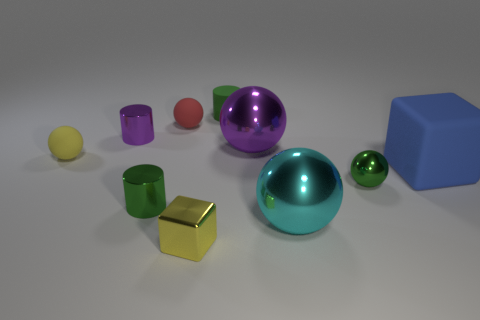What color is the matte cylinder? green 